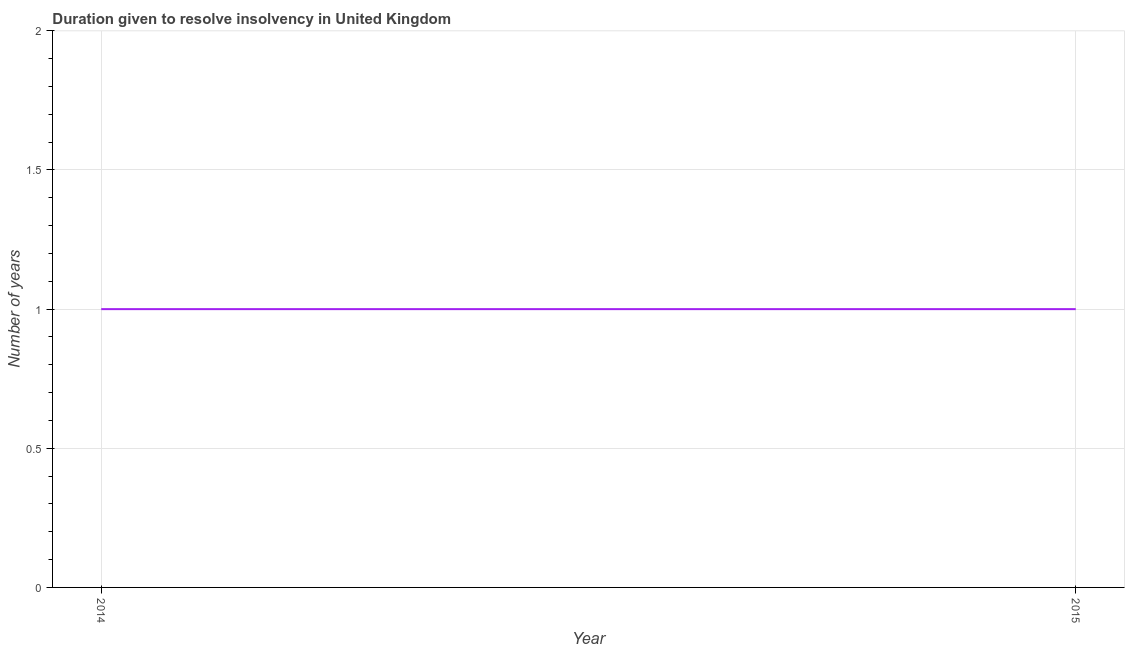What is the number of years to resolve insolvency in 2015?
Ensure brevity in your answer.  1. Across all years, what is the maximum number of years to resolve insolvency?
Ensure brevity in your answer.  1. Across all years, what is the minimum number of years to resolve insolvency?
Your response must be concise. 1. In which year was the number of years to resolve insolvency maximum?
Make the answer very short. 2014. What is the sum of the number of years to resolve insolvency?
Your response must be concise. 2. What is the average number of years to resolve insolvency per year?
Offer a terse response. 1. What is the median number of years to resolve insolvency?
Give a very brief answer. 1. In how many years, is the number of years to resolve insolvency greater than 1.6 ?
Offer a terse response. 0. Do a majority of the years between 2015 and 2014 (inclusive) have number of years to resolve insolvency greater than 1.6 ?
Provide a succinct answer. No. What is the ratio of the number of years to resolve insolvency in 2014 to that in 2015?
Offer a very short reply. 1. Is the number of years to resolve insolvency in 2014 less than that in 2015?
Provide a succinct answer. No. How many lines are there?
Ensure brevity in your answer.  1. How many years are there in the graph?
Your answer should be very brief. 2. Are the values on the major ticks of Y-axis written in scientific E-notation?
Your response must be concise. No. Does the graph contain any zero values?
Your answer should be compact. No. What is the title of the graph?
Keep it short and to the point. Duration given to resolve insolvency in United Kingdom. What is the label or title of the X-axis?
Offer a very short reply. Year. What is the label or title of the Y-axis?
Offer a very short reply. Number of years. What is the Number of years in 2014?
Keep it short and to the point. 1. What is the Number of years in 2015?
Offer a terse response. 1. What is the difference between the Number of years in 2014 and 2015?
Your answer should be very brief. 0. 